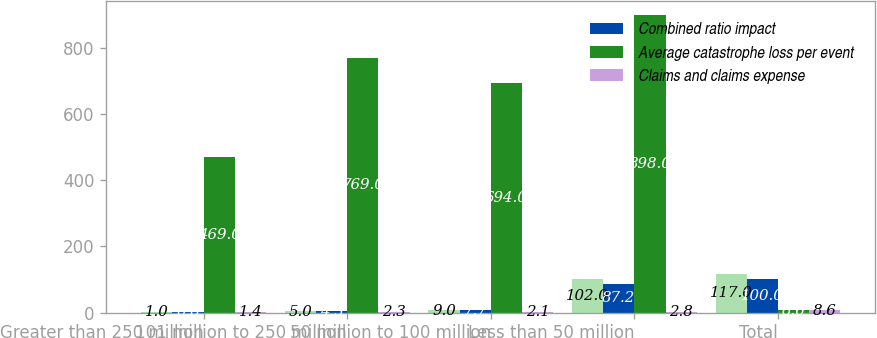Convert chart to OTSL. <chart><loc_0><loc_0><loc_500><loc_500><stacked_bar_chart><ecel><fcel>Greater than 250 million<fcel>101 million to 250 million<fcel>50 million to 100 million<fcel>Less than 50 million<fcel>Total<nl><fcel>nan<fcel>1<fcel>5<fcel>9<fcel>102<fcel>117<nl><fcel>Combined ratio impact<fcel>0.8<fcel>4.3<fcel>7.7<fcel>87.2<fcel>100<nl><fcel>Average catastrophe loss per event<fcel>469<fcel>769<fcel>694<fcel>898<fcel>8.6<nl><fcel>Claims and claims expense<fcel>1.4<fcel>2.3<fcel>2.1<fcel>2.8<fcel>8.6<nl></chart> 